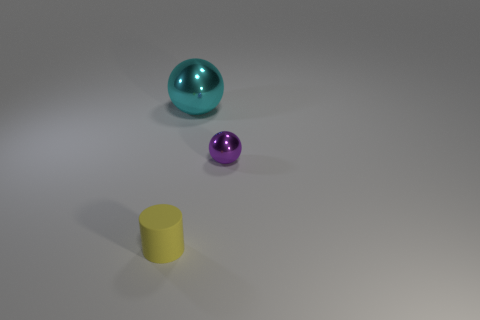Add 1 big balls. How many objects exist? 4 Subtract all balls. How many objects are left? 1 Add 1 spheres. How many spheres are left? 3 Add 2 cyan metal balls. How many cyan metal balls exist? 3 Subtract 0 gray blocks. How many objects are left? 3 Subtract all yellow rubber things. Subtract all shiny objects. How many objects are left? 0 